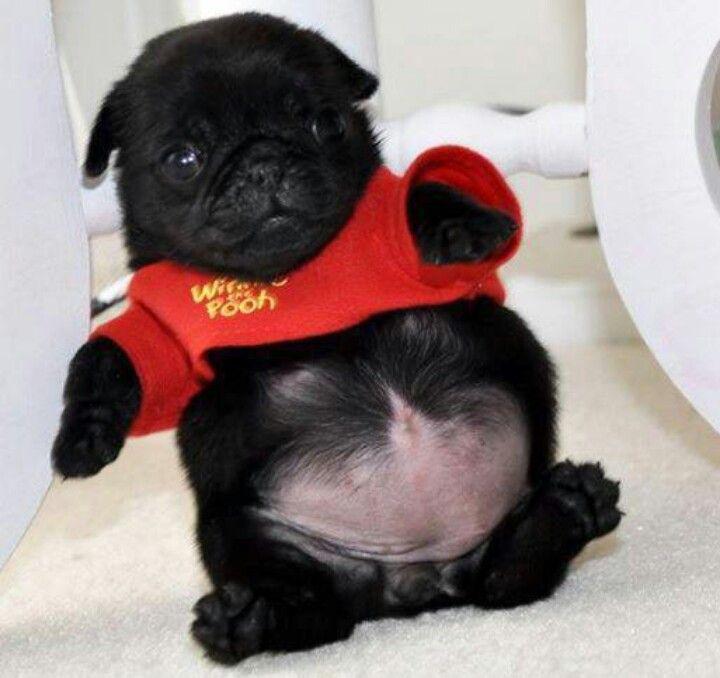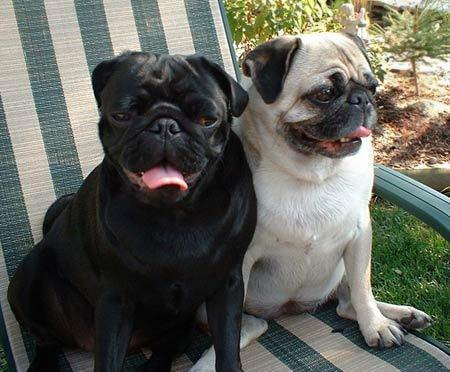The first image is the image on the left, the second image is the image on the right. For the images shown, is this caption "There is a pug lying on its back in the left image." true? Answer yes or no. Yes. The first image is the image on the left, the second image is the image on the right. Examine the images to the left and right. Is the description "A dog is wearing an accessory." accurate? Answer yes or no. Yes. 